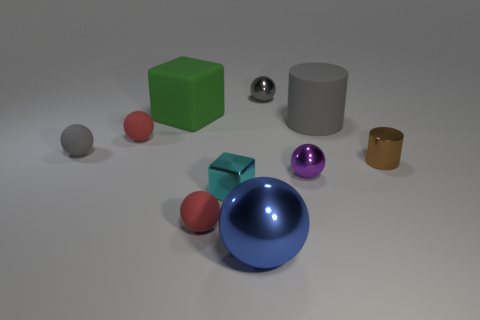Subtract all brown cubes. How many gray spheres are left? 2 Subtract all blue spheres. How many spheres are left? 5 Subtract all gray matte spheres. How many spheres are left? 5 Subtract all green balls. Subtract all cyan cylinders. How many balls are left? 6 Subtract all blocks. How many objects are left? 8 Add 9 purple spheres. How many purple spheres exist? 10 Subtract 0 cyan cylinders. How many objects are left? 10 Subtract all large rubber things. Subtract all tiny rubber balls. How many objects are left? 5 Add 2 small gray rubber things. How many small gray rubber things are left? 3 